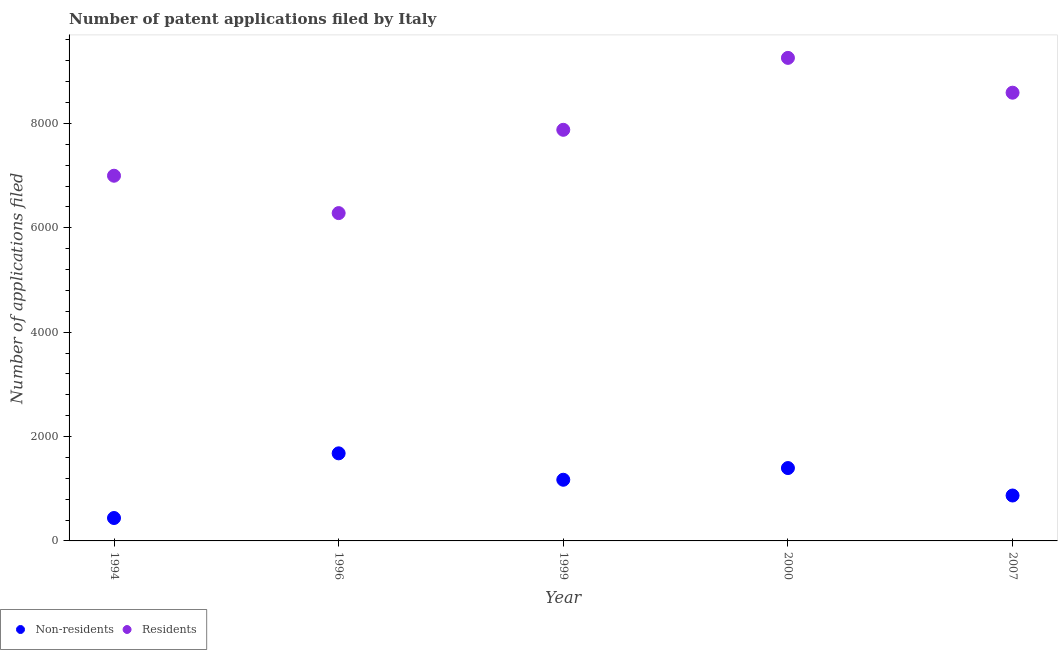How many different coloured dotlines are there?
Offer a terse response. 2. What is the number of patent applications by non residents in 2007?
Your response must be concise. 870. Across all years, what is the maximum number of patent applications by residents?
Provide a short and direct response. 9255. Across all years, what is the minimum number of patent applications by residents?
Offer a very short reply. 6281. In which year was the number of patent applications by non residents minimum?
Offer a very short reply. 1994. What is the total number of patent applications by non residents in the graph?
Your answer should be compact. 5555. What is the difference between the number of patent applications by residents in 1994 and that in 1996?
Give a very brief answer. 716. What is the difference between the number of patent applications by residents in 1999 and the number of patent applications by non residents in 1996?
Your response must be concise. 6199. What is the average number of patent applications by residents per year?
Offer a very short reply. 7799.6. In the year 1999, what is the difference between the number of patent applications by residents and number of patent applications by non residents?
Keep it short and to the point. 6705. What is the ratio of the number of patent applications by non residents in 1996 to that in 2000?
Make the answer very short. 1.2. Is the difference between the number of patent applications by residents in 1994 and 2000 greater than the difference between the number of patent applications by non residents in 1994 and 2000?
Your response must be concise. No. What is the difference between the highest and the second highest number of patent applications by non residents?
Your answer should be very brief. 282. What is the difference between the highest and the lowest number of patent applications by non residents?
Your answer should be compact. 1239. Is the number of patent applications by non residents strictly less than the number of patent applications by residents over the years?
Your answer should be very brief. Yes. How many dotlines are there?
Give a very brief answer. 2. How many years are there in the graph?
Offer a terse response. 5. Where does the legend appear in the graph?
Your answer should be very brief. Bottom left. How many legend labels are there?
Make the answer very short. 2. What is the title of the graph?
Offer a terse response. Number of patent applications filed by Italy. Does "Arms imports" appear as one of the legend labels in the graph?
Keep it short and to the point. No. What is the label or title of the X-axis?
Your answer should be compact. Year. What is the label or title of the Y-axis?
Provide a short and direct response. Number of applications filed. What is the Number of applications filed in Non-residents in 1994?
Offer a terse response. 439. What is the Number of applications filed in Residents in 1994?
Provide a short and direct response. 6997. What is the Number of applications filed of Non-residents in 1996?
Your answer should be compact. 1678. What is the Number of applications filed in Residents in 1996?
Your response must be concise. 6281. What is the Number of applications filed in Non-residents in 1999?
Keep it short and to the point. 1172. What is the Number of applications filed in Residents in 1999?
Ensure brevity in your answer.  7877. What is the Number of applications filed of Non-residents in 2000?
Offer a very short reply. 1396. What is the Number of applications filed in Residents in 2000?
Your answer should be compact. 9255. What is the Number of applications filed in Non-residents in 2007?
Keep it short and to the point. 870. What is the Number of applications filed in Residents in 2007?
Provide a short and direct response. 8588. Across all years, what is the maximum Number of applications filed in Non-residents?
Give a very brief answer. 1678. Across all years, what is the maximum Number of applications filed of Residents?
Ensure brevity in your answer.  9255. Across all years, what is the minimum Number of applications filed of Non-residents?
Give a very brief answer. 439. Across all years, what is the minimum Number of applications filed in Residents?
Make the answer very short. 6281. What is the total Number of applications filed in Non-residents in the graph?
Offer a terse response. 5555. What is the total Number of applications filed in Residents in the graph?
Offer a terse response. 3.90e+04. What is the difference between the Number of applications filed in Non-residents in 1994 and that in 1996?
Your answer should be very brief. -1239. What is the difference between the Number of applications filed of Residents in 1994 and that in 1996?
Provide a short and direct response. 716. What is the difference between the Number of applications filed of Non-residents in 1994 and that in 1999?
Your answer should be compact. -733. What is the difference between the Number of applications filed in Residents in 1994 and that in 1999?
Offer a very short reply. -880. What is the difference between the Number of applications filed of Non-residents in 1994 and that in 2000?
Provide a short and direct response. -957. What is the difference between the Number of applications filed in Residents in 1994 and that in 2000?
Your answer should be compact. -2258. What is the difference between the Number of applications filed in Non-residents in 1994 and that in 2007?
Ensure brevity in your answer.  -431. What is the difference between the Number of applications filed of Residents in 1994 and that in 2007?
Offer a terse response. -1591. What is the difference between the Number of applications filed in Non-residents in 1996 and that in 1999?
Offer a terse response. 506. What is the difference between the Number of applications filed in Residents in 1996 and that in 1999?
Your response must be concise. -1596. What is the difference between the Number of applications filed in Non-residents in 1996 and that in 2000?
Your answer should be compact. 282. What is the difference between the Number of applications filed in Residents in 1996 and that in 2000?
Your answer should be compact. -2974. What is the difference between the Number of applications filed in Non-residents in 1996 and that in 2007?
Offer a very short reply. 808. What is the difference between the Number of applications filed in Residents in 1996 and that in 2007?
Make the answer very short. -2307. What is the difference between the Number of applications filed in Non-residents in 1999 and that in 2000?
Offer a terse response. -224. What is the difference between the Number of applications filed in Residents in 1999 and that in 2000?
Keep it short and to the point. -1378. What is the difference between the Number of applications filed in Non-residents in 1999 and that in 2007?
Keep it short and to the point. 302. What is the difference between the Number of applications filed in Residents in 1999 and that in 2007?
Your answer should be very brief. -711. What is the difference between the Number of applications filed of Non-residents in 2000 and that in 2007?
Ensure brevity in your answer.  526. What is the difference between the Number of applications filed in Residents in 2000 and that in 2007?
Make the answer very short. 667. What is the difference between the Number of applications filed in Non-residents in 1994 and the Number of applications filed in Residents in 1996?
Provide a short and direct response. -5842. What is the difference between the Number of applications filed of Non-residents in 1994 and the Number of applications filed of Residents in 1999?
Offer a very short reply. -7438. What is the difference between the Number of applications filed in Non-residents in 1994 and the Number of applications filed in Residents in 2000?
Your response must be concise. -8816. What is the difference between the Number of applications filed of Non-residents in 1994 and the Number of applications filed of Residents in 2007?
Make the answer very short. -8149. What is the difference between the Number of applications filed of Non-residents in 1996 and the Number of applications filed of Residents in 1999?
Provide a succinct answer. -6199. What is the difference between the Number of applications filed in Non-residents in 1996 and the Number of applications filed in Residents in 2000?
Ensure brevity in your answer.  -7577. What is the difference between the Number of applications filed in Non-residents in 1996 and the Number of applications filed in Residents in 2007?
Keep it short and to the point. -6910. What is the difference between the Number of applications filed of Non-residents in 1999 and the Number of applications filed of Residents in 2000?
Make the answer very short. -8083. What is the difference between the Number of applications filed in Non-residents in 1999 and the Number of applications filed in Residents in 2007?
Ensure brevity in your answer.  -7416. What is the difference between the Number of applications filed of Non-residents in 2000 and the Number of applications filed of Residents in 2007?
Your answer should be compact. -7192. What is the average Number of applications filed in Non-residents per year?
Offer a terse response. 1111. What is the average Number of applications filed in Residents per year?
Ensure brevity in your answer.  7799.6. In the year 1994, what is the difference between the Number of applications filed in Non-residents and Number of applications filed in Residents?
Ensure brevity in your answer.  -6558. In the year 1996, what is the difference between the Number of applications filed in Non-residents and Number of applications filed in Residents?
Provide a short and direct response. -4603. In the year 1999, what is the difference between the Number of applications filed of Non-residents and Number of applications filed of Residents?
Your answer should be compact. -6705. In the year 2000, what is the difference between the Number of applications filed of Non-residents and Number of applications filed of Residents?
Give a very brief answer. -7859. In the year 2007, what is the difference between the Number of applications filed in Non-residents and Number of applications filed in Residents?
Give a very brief answer. -7718. What is the ratio of the Number of applications filed of Non-residents in 1994 to that in 1996?
Your answer should be compact. 0.26. What is the ratio of the Number of applications filed of Residents in 1994 to that in 1996?
Ensure brevity in your answer.  1.11. What is the ratio of the Number of applications filed of Non-residents in 1994 to that in 1999?
Make the answer very short. 0.37. What is the ratio of the Number of applications filed in Residents in 1994 to that in 1999?
Provide a short and direct response. 0.89. What is the ratio of the Number of applications filed in Non-residents in 1994 to that in 2000?
Your answer should be very brief. 0.31. What is the ratio of the Number of applications filed of Residents in 1994 to that in 2000?
Provide a short and direct response. 0.76. What is the ratio of the Number of applications filed in Non-residents in 1994 to that in 2007?
Ensure brevity in your answer.  0.5. What is the ratio of the Number of applications filed in Residents in 1994 to that in 2007?
Keep it short and to the point. 0.81. What is the ratio of the Number of applications filed in Non-residents in 1996 to that in 1999?
Provide a succinct answer. 1.43. What is the ratio of the Number of applications filed of Residents in 1996 to that in 1999?
Provide a succinct answer. 0.8. What is the ratio of the Number of applications filed of Non-residents in 1996 to that in 2000?
Your answer should be very brief. 1.2. What is the ratio of the Number of applications filed in Residents in 1996 to that in 2000?
Give a very brief answer. 0.68. What is the ratio of the Number of applications filed of Non-residents in 1996 to that in 2007?
Offer a terse response. 1.93. What is the ratio of the Number of applications filed in Residents in 1996 to that in 2007?
Your response must be concise. 0.73. What is the ratio of the Number of applications filed of Non-residents in 1999 to that in 2000?
Your answer should be very brief. 0.84. What is the ratio of the Number of applications filed in Residents in 1999 to that in 2000?
Your response must be concise. 0.85. What is the ratio of the Number of applications filed in Non-residents in 1999 to that in 2007?
Offer a very short reply. 1.35. What is the ratio of the Number of applications filed of Residents in 1999 to that in 2007?
Provide a succinct answer. 0.92. What is the ratio of the Number of applications filed in Non-residents in 2000 to that in 2007?
Offer a terse response. 1.6. What is the ratio of the Number of applications filed in Residents in 2000 to that in 2007?
Your answer should be compact. 1.08. What is the difference between the highest and the second highest Number of applications filed in Non-residents?
Your response must be concise. 282. What is the difference between the highest and the second highest Number of applications filed in Residents?
Ensure brevity in your answer.  667. What is the difference between the highest and the lowest Number of applications filed of Non-residents?
Keep it short and to the point. 1239. What is the difference between the highest and the lowest Number of applications filed of Residents?
Offer a terse response. 2974. 